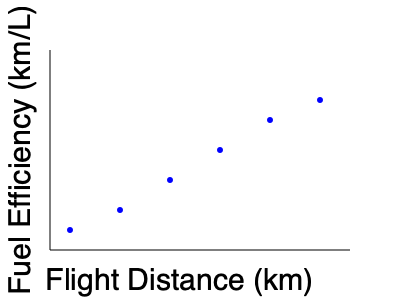Based on the scatter plot showing the relationship between flight distance and fuel efficiency, what general trend can be observed, and how might this information be relevant for a climate economist analyzing the financial implications of reducing aviation emissions? To analyze the scatter plot and its relevance to a climate economist, let's follow these steps:

1. Observe the trend:
   The scatter plot shows a clear negative correlation between flight distance and fuel efficiency. As the flight distance increases, the fuel efficiency decreases.

2. Interpret the relationship:
   Shorter flights tend to have higher fuel efficiency (more km traveled per liter of fuel), while longer flights have lower fuel efficiency.

3. Understand the implications:
   a) Emissions impact: Longer flights are likely to produce more emissions per kilometer traveled due to lower fuel efficiency.
   b) Cost considerations: Fuel costs for longer flights may be disproportionately higher due to decreased efficiency.

4. Relevance for a climate economist:
   a) Policy implications: This data could inform policies aimed at reducing aviation emissions, such as incentivizing shorter flights or improving long-haul flight efficiency.
   b) Carbon pricing: When designing carbon pricing mechanisms for the aviation sector, the economist might need to consider the varying efficiency across flight distances.
   c) Technology investment: The data suggests a need for focusing on improving fuel efficiency for longer flights, which could guide investment decisions in aviation technology.
   d) route optimization: Airlines might be encouraged to optimize their routes to balance between distance and efficiency, potentially leading to reduced overall emissions.

5. Financial analysis:
   The economist could use this information to model the financial impacts of various emission reduction strategies, considering the trade-offs between flight distances, fuel costs, and potential carbon taxes or credits.
Answer: As flight distance increases, fuel efficiency decreases, implying higher emissions and costs for longer flights. This trend is crucial for developing targeted policies, carbon pricing mechanisms, and technology investments to reduce aviation emissions cost-effectively. 